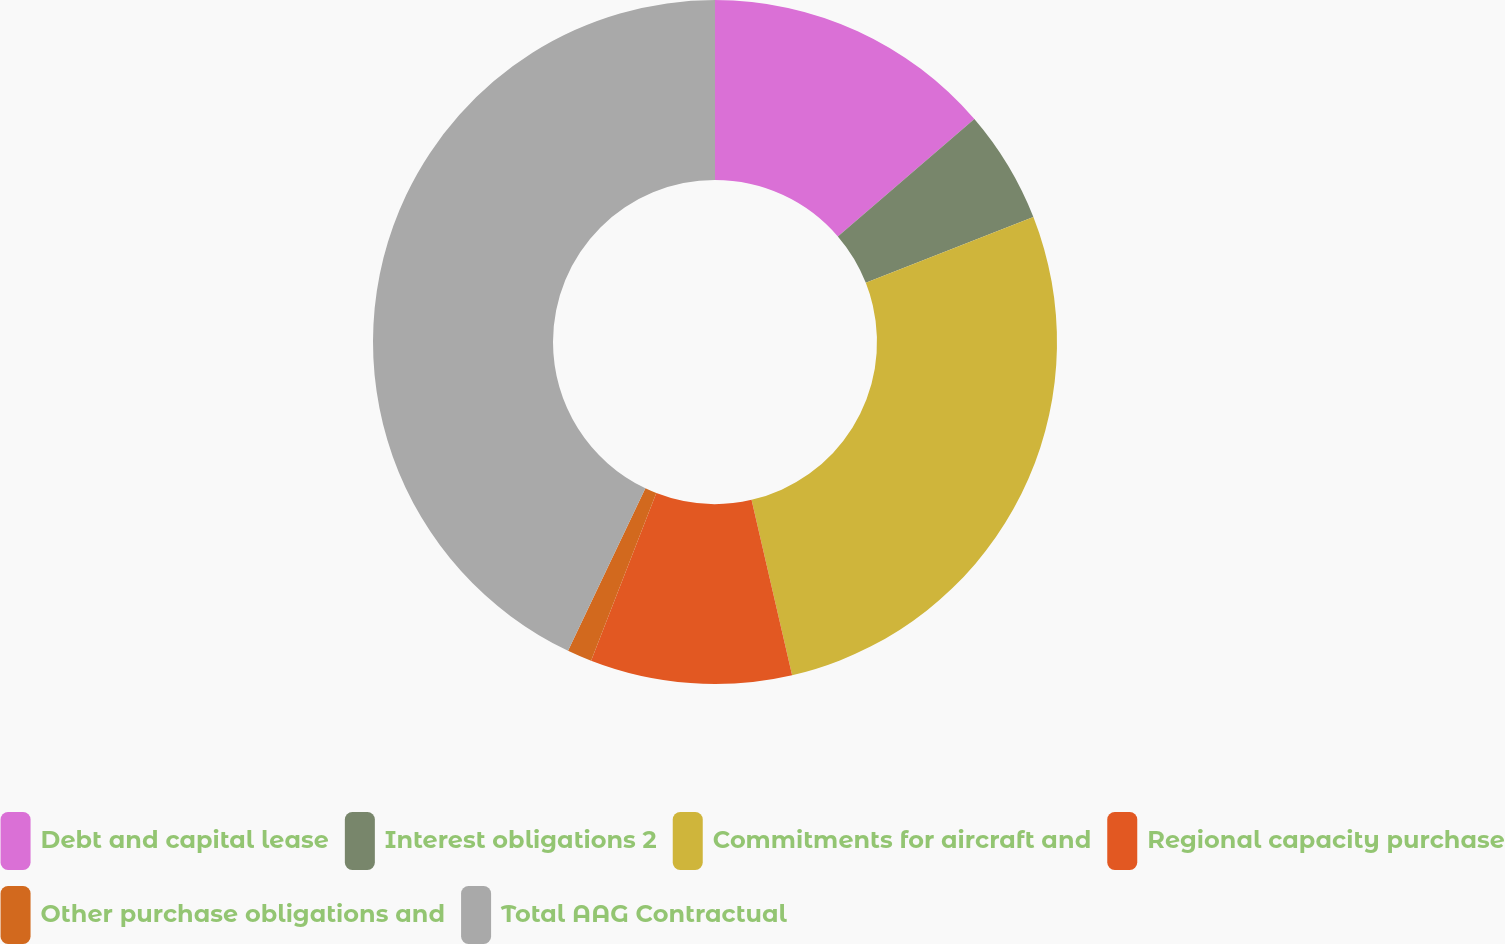Convert chart to OTSL. <chart><loc_0><loc_0><loc_500><loc_500><pie_chart><fcel>Debt and capital lease<fcel>Interest obligations 2<fcel>Commitments for aircraft and<fcel>Regional capacity purchase<fcel>Other purchase obligations and<fcel>Total AAG Contractual<nl><fcel>13.7%<fcel>5.35%<fcel>27.33%<fcel>9.52%<fcel>1.17%<fcel>42.93%<nl></chart> 